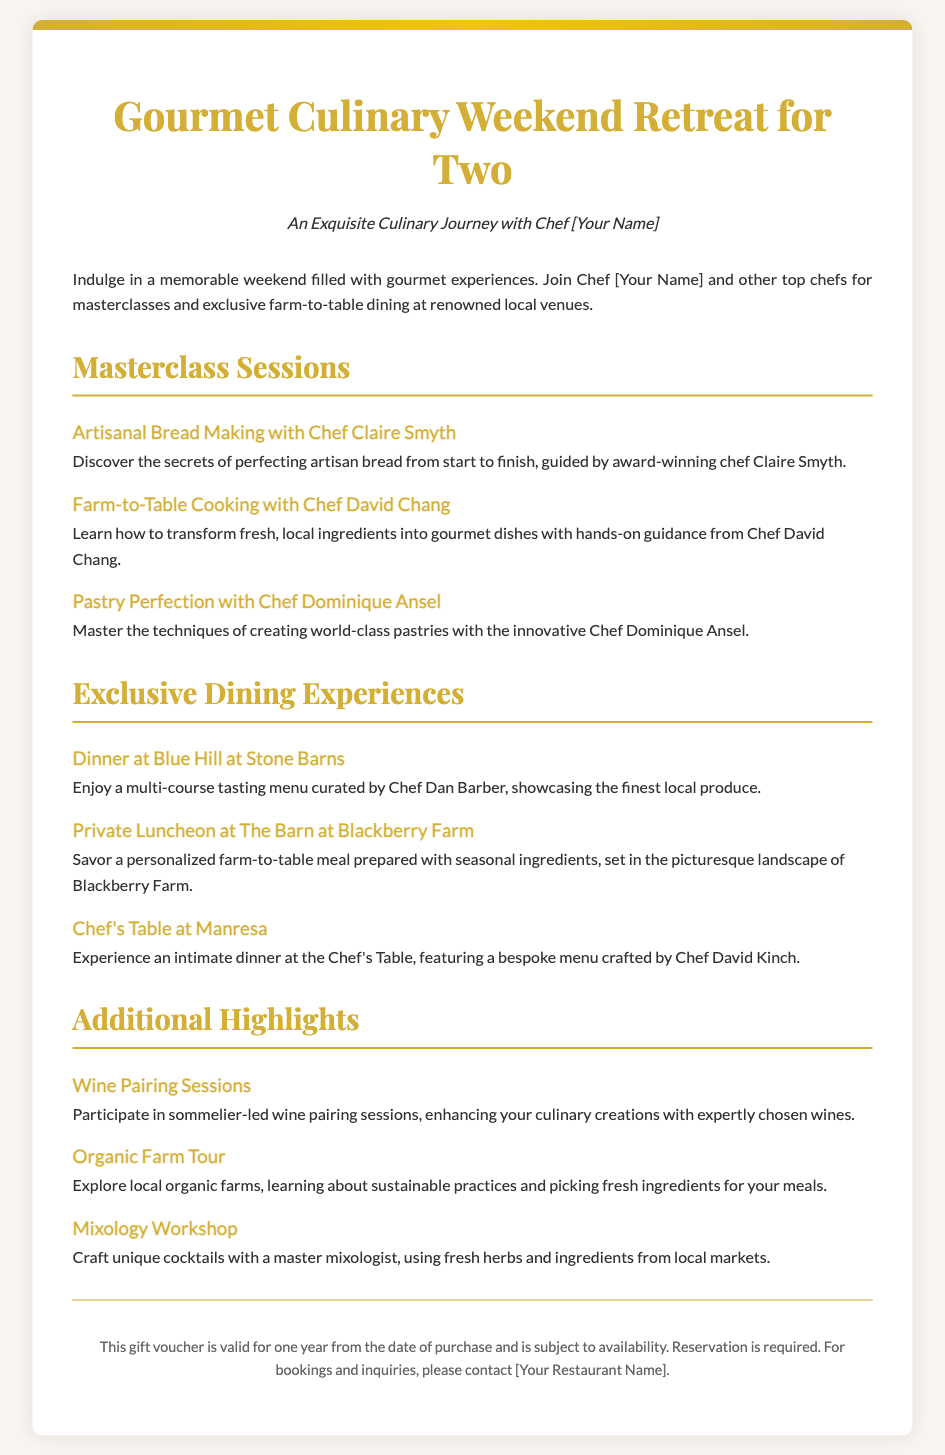What is the title of the retreat? The title of the retreat is stated at the top of the document.
Answer: Gourmet Culinary Weekend Retreat for Two Who will conduct the artisanal bread making masterclass? The document specifies the chef leading this masterclass, indicating a specific individual.
Answer: Chef Claire Smyth How many exclusive dining experiences are listed? The document enumerates the exclusive dining experiences, allowing for a simple count.
Answer: Three What type of workshop is included in the additional highlights? The document mentions a specific type of workshop included in the experiences, indicating its type.
Answer: Mixology Workshop What is the validity period of the gift voucher? The document mentions a specific period that denotes how long the voucher can be redeemed.
Answer: One year Which chef is responsible for the dinner at Blue Hill at Stone Barns? The document identifies the chef responsible for this dining experience, stating it explicitly.
Answer: Chef Dan Barber What is required for making a reservation? The document states a specific action necessary to secure a booking for the retreat.
Answer: Reservation is required What is one activity offered in the organic farm tour? The document lists activities involved in the organic farm tour, pointing out a key feature.
Answer: Picking fresh ingredients 